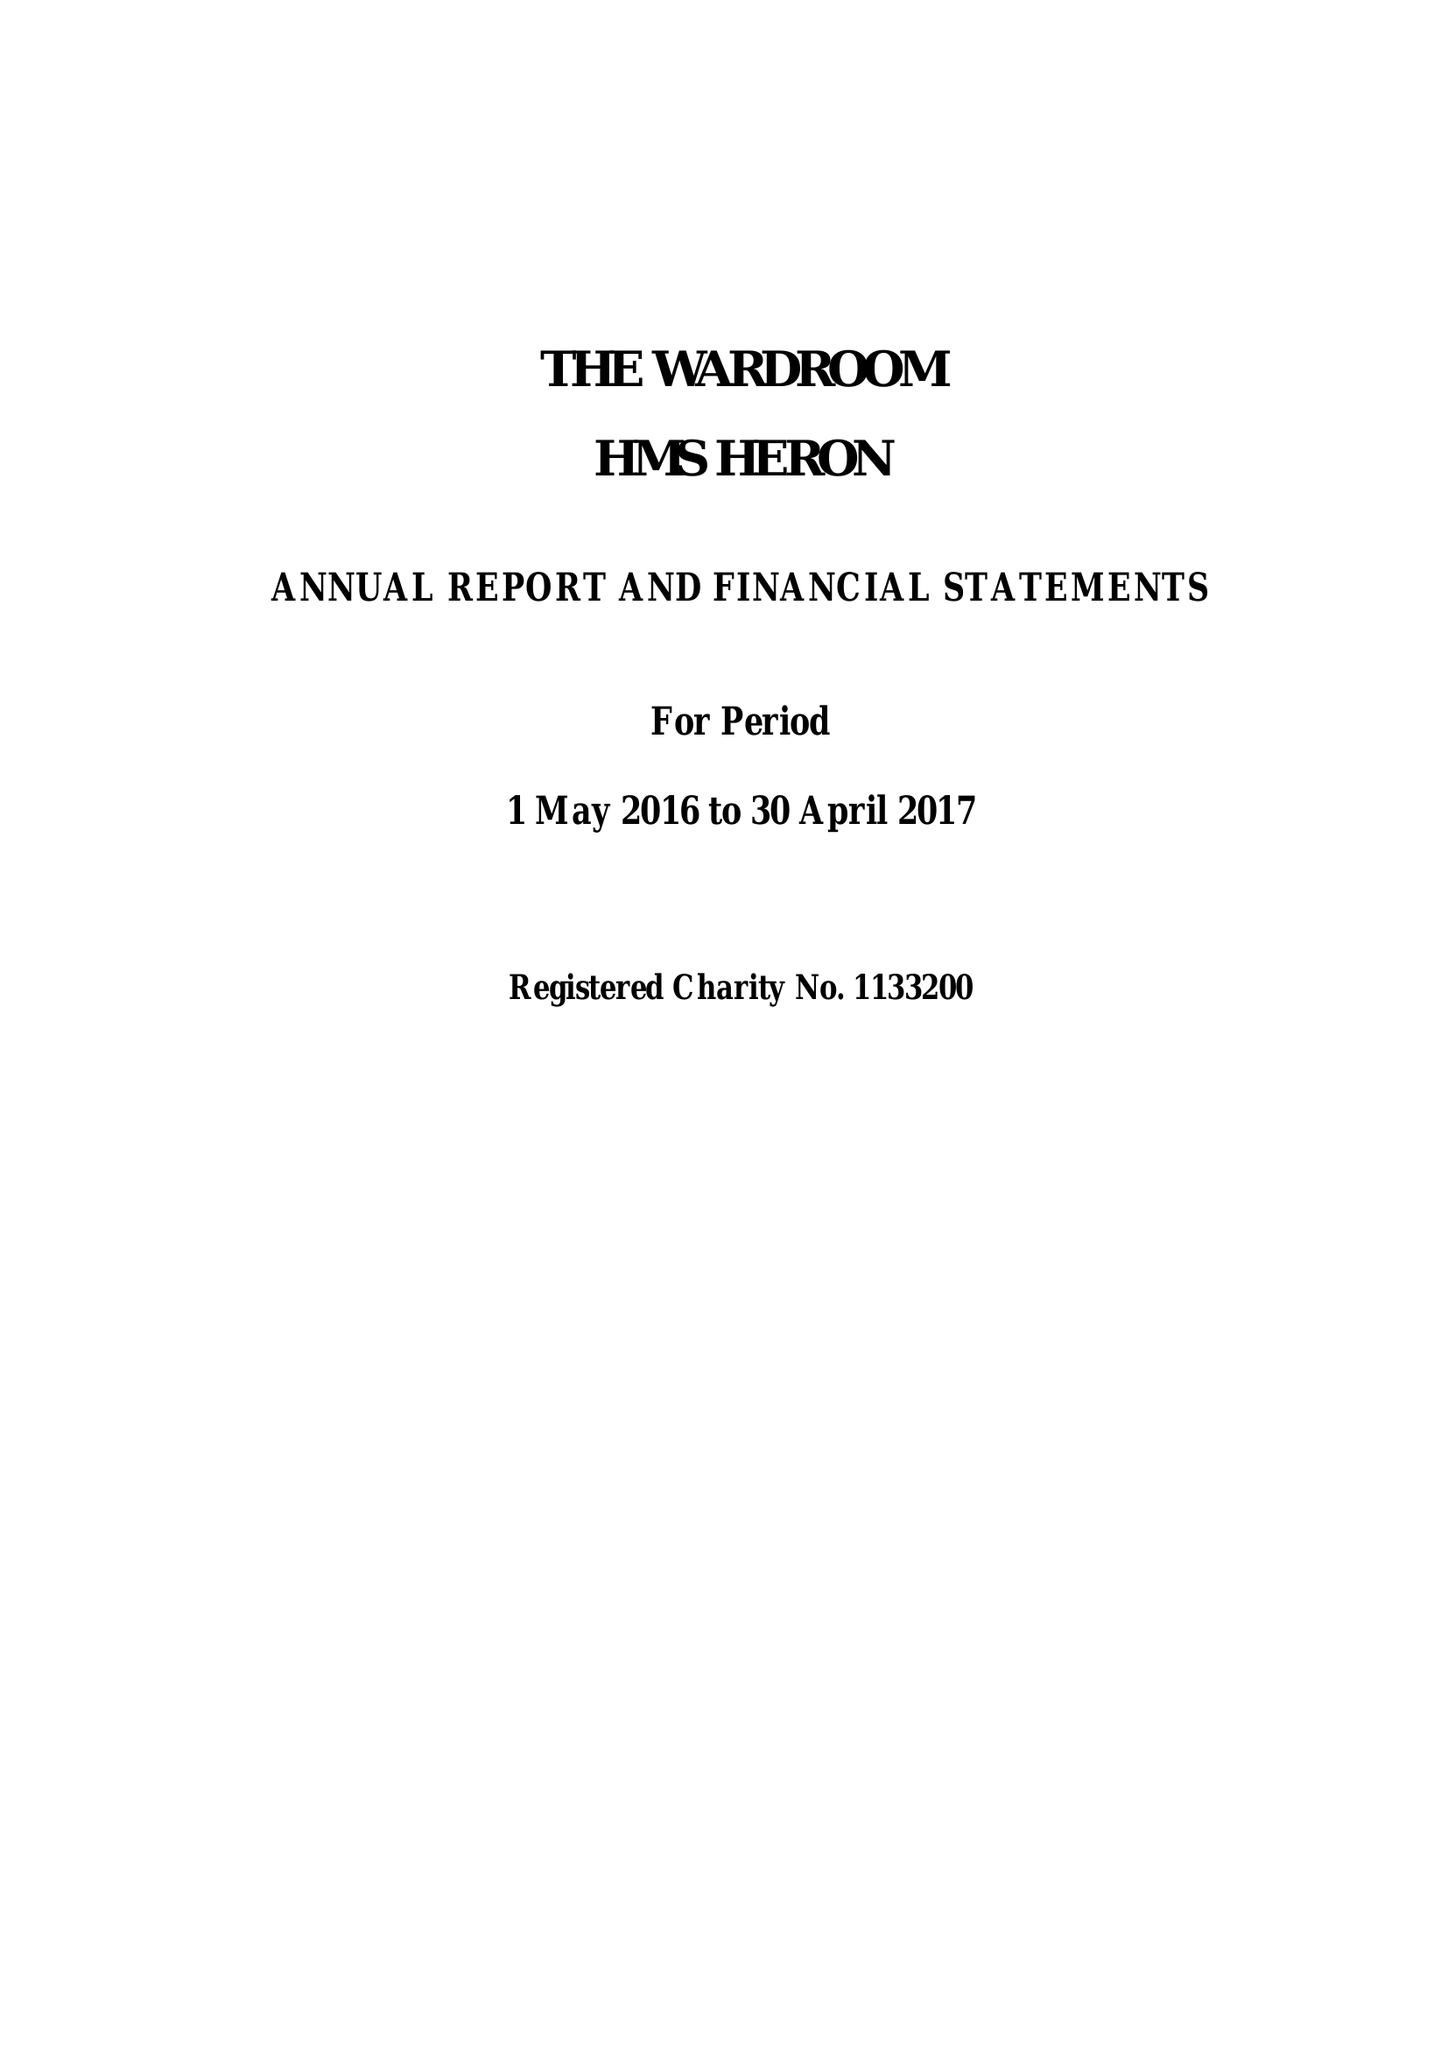What is the value for the charity_name?
Answer the question using a single word or phrase. Wardroom Mess Hms Heron 